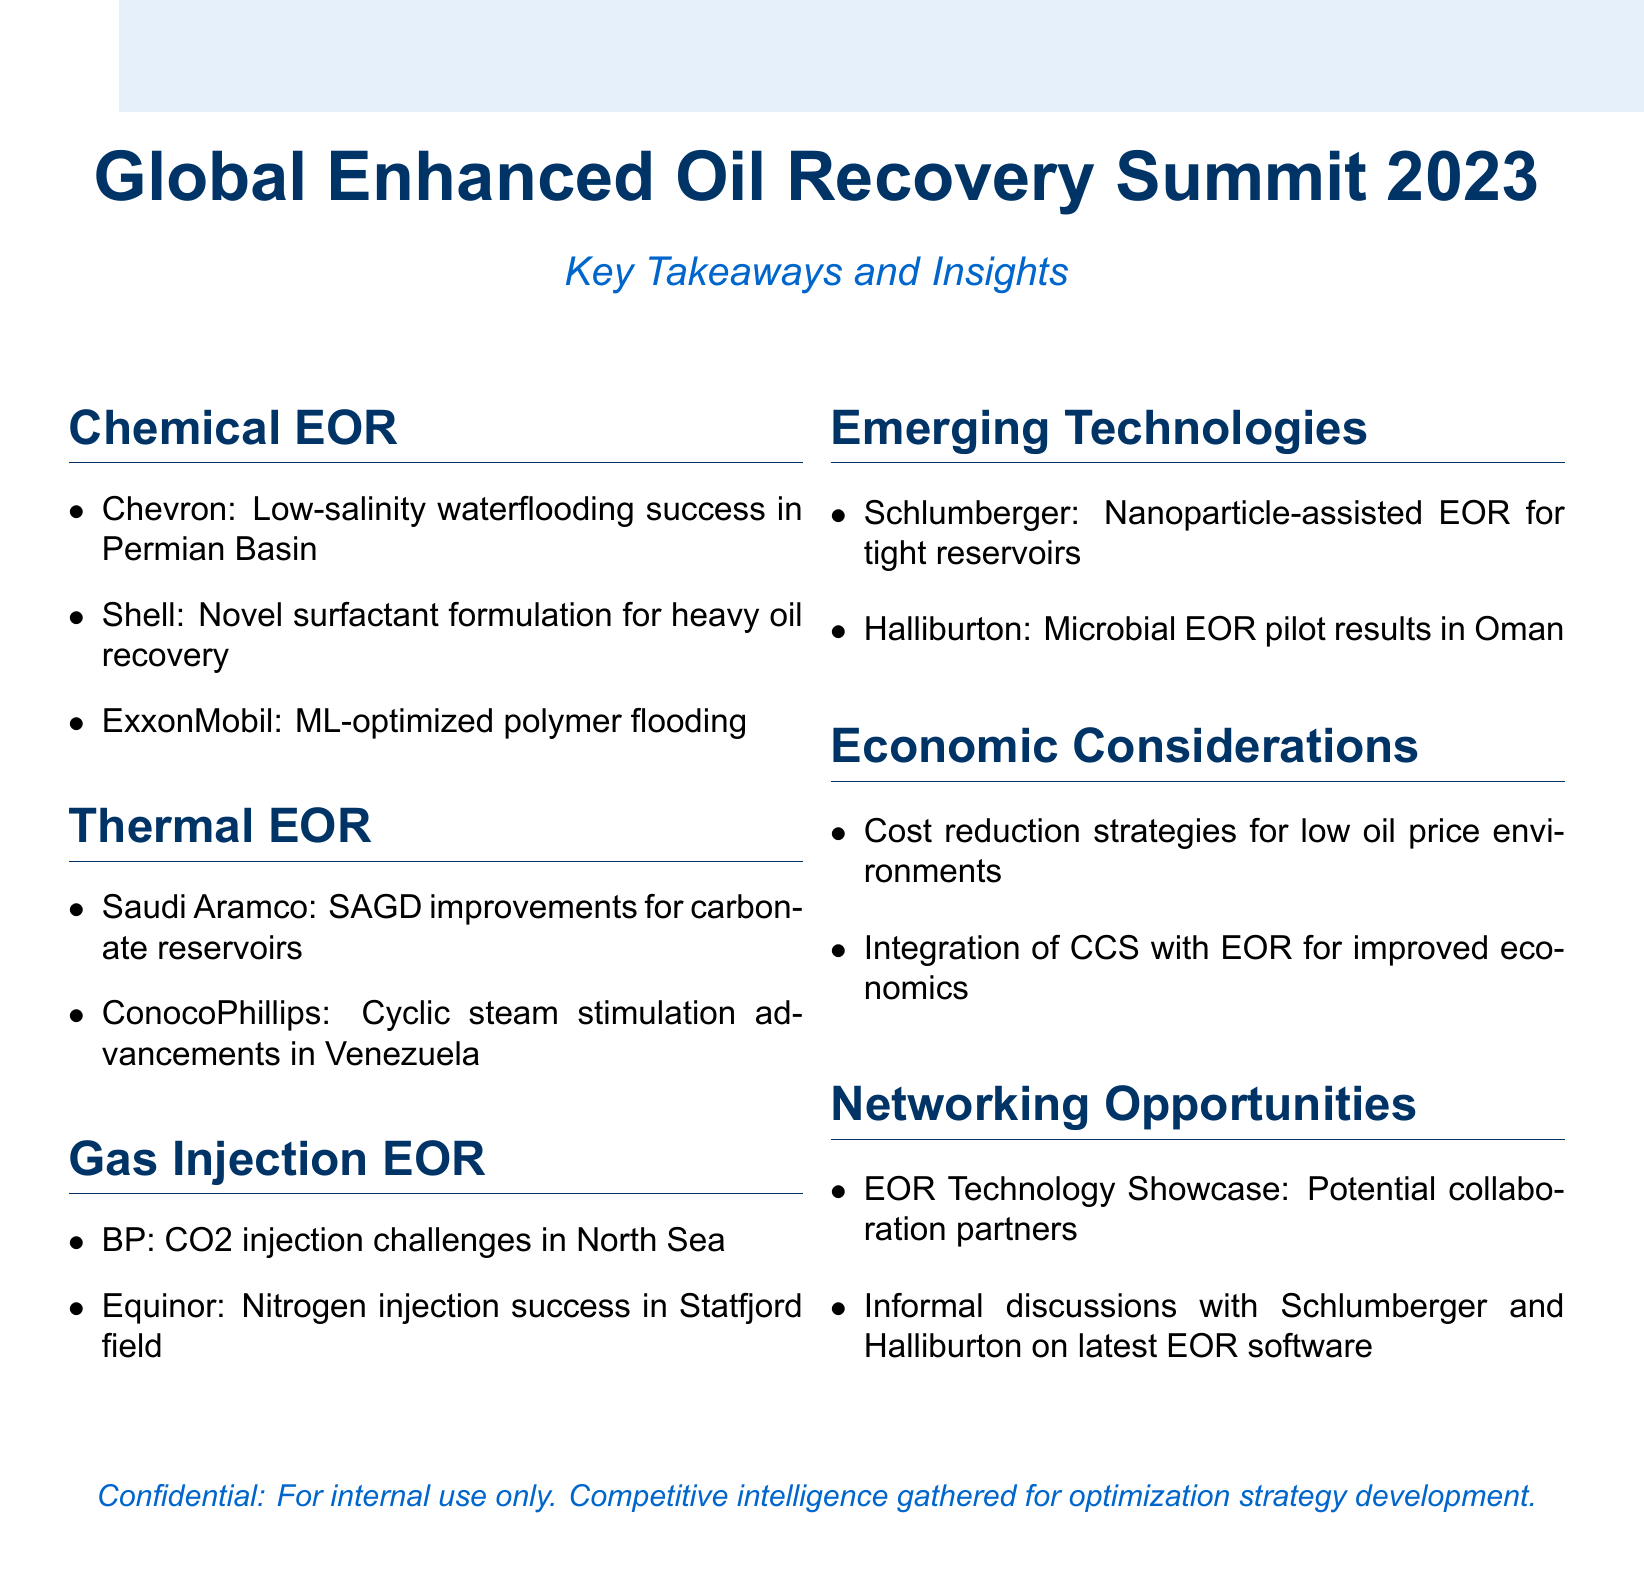What technique did Chevron succeed with in the Permian Basin? The technique mentioned is low-salinity waterflooding, highlighted in the Chemical EOR section.
Answer: low-salinity waterflooding What company developed a novel surfactant formulation for heavy oil recovery? The company mentioned in the Chemical EOR section is Shell, indicating their innovation in surfactants.
Answer: Shell Which method did ExxonMobil optimize using machine learning? The method referred to is polymer flooding, which is noted in the Chemical EOR section.
Answer: polymer flooding What improvements did Saudi Aramco achieve for carbonate reservoirs? Saudi Aramco's advancements mentioned are related to SAGD improvements, found in the Thermal EOR section.
Answer: SAGD improvements What project did BP conduct in the North Sea? BP's project is a CO2 injection project, as described in the Gas Injection EOR section.
Answer: CO2 injection project Which two emerging technologies are highlighted in the document? The technologies cited are nanoparticle-assisted EOR and microbial EOR pilot results, referencing Schlumberger and Halliburton, respectively.
Answer: nanoparticle-assisted EOR, microbial EOR What is a cost reduction strategy for EOR projects mentioned in the document? The document discusses strategies for operating in low oil price environments under the Economic Considerations section.
Answer: low oil price environments What networking opportunity is outlined in the document? A specific opportunity is the EOR Technology Showcase, mentioned in the Networking Opportunities section.
Answer: EOR Technology Showcase Who had informal discussions about the latest EOR software? The discussions involved representatives from Schlumberger and Halliburton, as indicated in the Networking Opportunities.
Answer: Schlumberger and Halliburton 